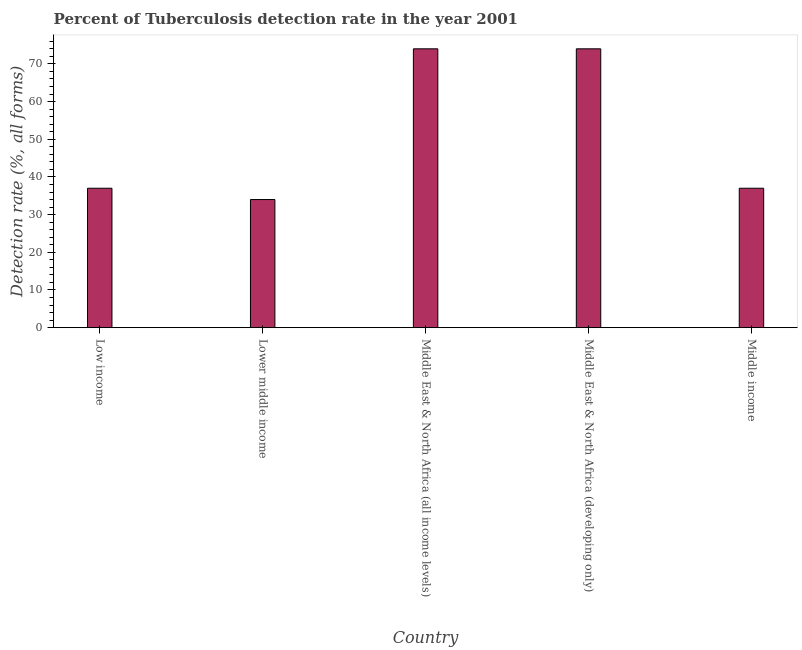What is the title of the graph?
Offer a terse response. Percent of Tuberculosis detection rate in the year 2001. What is the label or title of the Y-axis?
Your response must be concise. Detection rate (%, all forms). What is the detection rate of tuberculosis in Middle income?
Offer a very short reply. 37. In which country was the detection rate of tuberculosis maximum?
Provide a succinct answer. Middle East & North Africa (all income levels). In which country was the detection rate of tuberculosis minimum?
Provide a short and direct response. Lower middle income. What is the sum of the detection rate of tuberculosis?
Keep it short and to the point. 256. What is the average detection rate of tuberculosis per country?
Provide a succinct answer. 51.2. What is the median detection rate of tuberculosis?
Provide a short and direct response. 37. In how many countries, is the detection rate of tuberculosis greater than 22 %?
Your response must be concise. 5. Is the detection rate of tuberculosis in Lower middle income less than that in Middle East & North Africa (developing only)?
Your answer should be very brief. Yes. What is the difference between the highest and the second highest detection rate of tuberculosis?
Your answer should be compact. 0. Is the sum of the detection rate of tuberculosis in Lower middle income and Middle income greater than the maximum detection rate of tuberculosis across all countries?
Offer a very short reply. No. What is the difference between the highest and the lowest detection rate of tuberculosis?
Offer a very short reply. 40. Are all the bars in the graph horizontal?
Provide a short and direct response. No. What is the Detection rate (%, all forms) of Low income?
Your response must be concise. 37. What is the Detection rate (%, all forms) in Lower middle income?
Offer a very short reply. 34. What is the Detection rate (%, all forms) of Middle East & North Africa (all income levels)?
Offer a very short reply. 74. What is the difference between the Detection rate (%, all forms) in Low income and Middle East & North Africa (all income levels)?
Keep it short and to the point. -37. What is the difference between the Detection rate (%, all forms) in Low income and Middle East & North Africa (developing only)?
Provide a succinct answer. -37. What is the difference between the Detection rate (%, all forms) in Lower middle income and Middle East & North Africa (developing only)?
Ensure brevity in your answer.  -40. What is the difference between the Detection rate (%, all forms) in Middle East & North Africa (all income levels) and Middle East & North Africa (developing only)?
Your response must be concise. 0. What is the difference between the Detection rate (%, all forms) in Middle East & North Africa (developing only) and Middle income?
Make the answer very short. 37. What is the ratio of the Detection rate (%, all forms) in Low income to that in Lower middle income?
Provide a succinct answer. 1.09. What is the ratio of the Detection rate (%, all forms) in Low income to that in Middle East & North Africa (all income levels)?
Your response must be concise. 0.5. What is the ratio of the Detection rate (%, all forms) in Low income to that in Middle East & North Africa (developing only)?
Your response must be concise. 0.5. What is the ratio of the Detection rate (%, all forms) in Lower middle income to that in Middle East & North Africa (all income levels)?
Make the answer very short. 0.46. What is the ratio of the Detection rate (%, all forms) in Lower middle income to that in Middle East & North Africa (developing only)?
Give a very brief answer. 0.46. What is the ratio of the Detection rate (%, all forms) in Lower middle income to that in Middle income?
Make the answer very short. 0.92. 